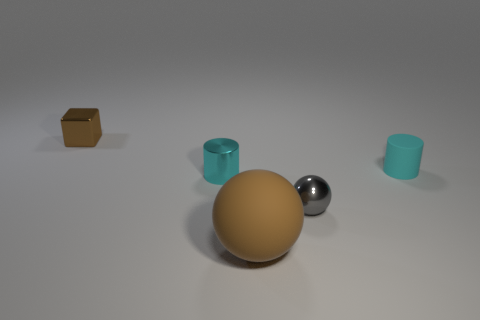Add 5 small gray metallic balls. How many objects exist? 10 Subtract all blocks. How many objects are left? 4 Subtract 0 blue cylinders. How many objects are left? 5 Subtract all small cyan shiny cylinders. Subtract all gray metal spheres. How many objects are left? 3 Add 3 brown spheres. How many brown spheres are left? 4 Add 4 small shiny cylinders. How many small shiny cylinders exist? 5 